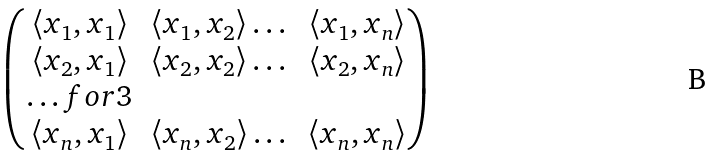Convert formula to latex. <formula><loc_0><loc_0><loc_500><loc_500>\begin{pmatrix} \langle x _ { 1 } , x _ { 1 } \rangle & \langle x _ { 1 } , x _ { 2 } \rangle \dots & \langle x _ { 1 } , x _ { n } \rangle \\ \langle x _ { 2 } , x _ { 1 } \rangle & \langle x _ { 2 } , x _ { 2 } \rangle \dots & \langle x _ { 2 } , x _ { n } \rangle \\ \hdots f o r { 3 } \\ \langle x _ { n } , x _ { 1 } \rangle & \langle x _ { n } , x _ { 2 } \rangle \dots & \langle x _ { n } , x _ { n } \rangle \end{pmatrix}</formula> 